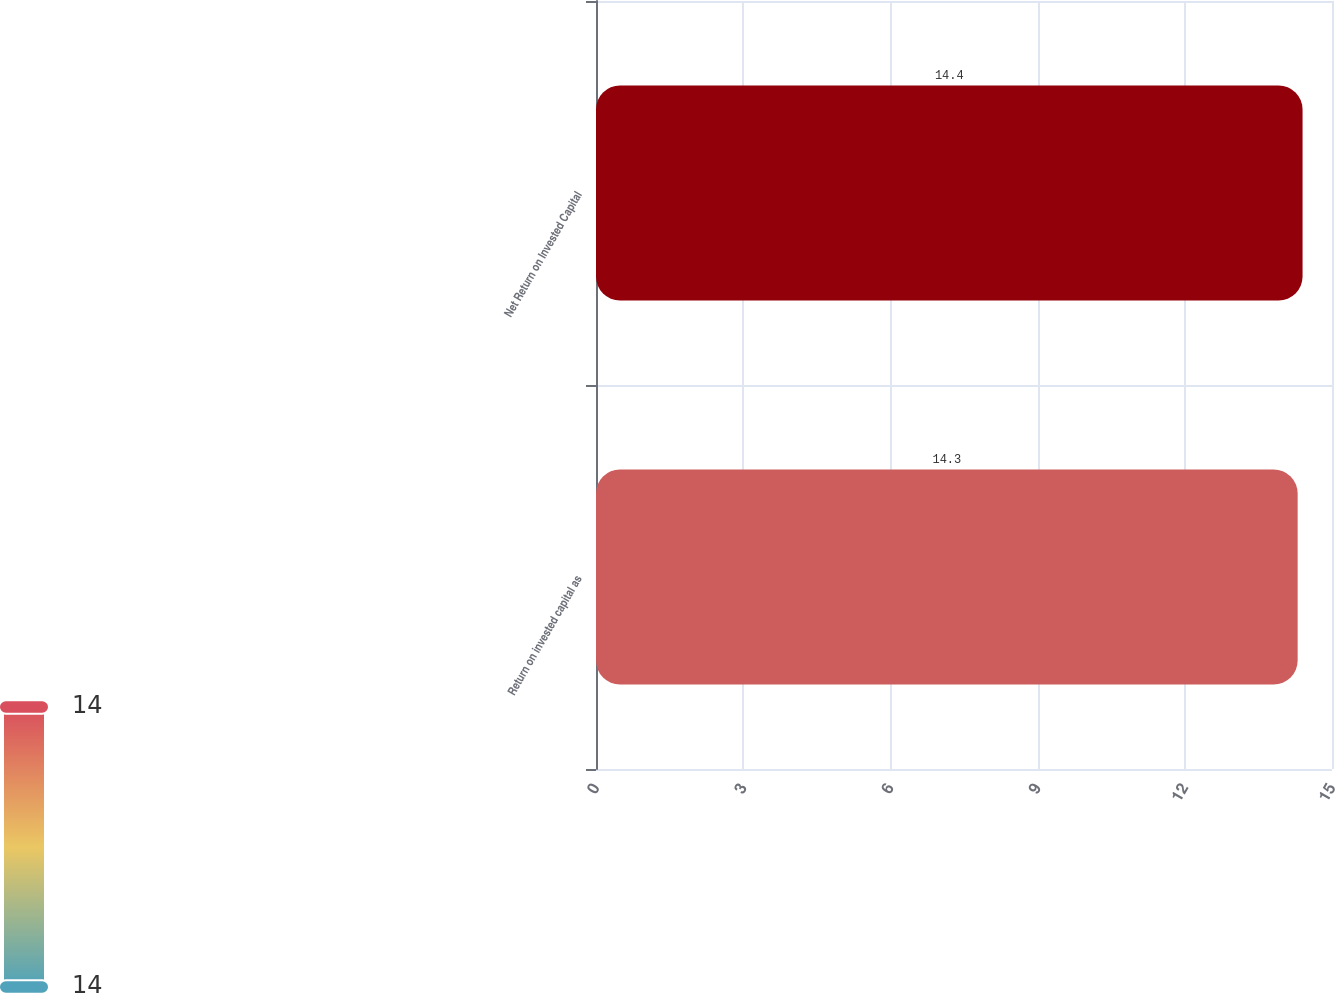<chart> <loc_0><loc_0><loc_500><loc_500><bar_chart><fcel>Return on invested capital as<fcel>Net Return on Invested Capital<nl><fcel>14.3<fcel>14.4<nl></chart> 